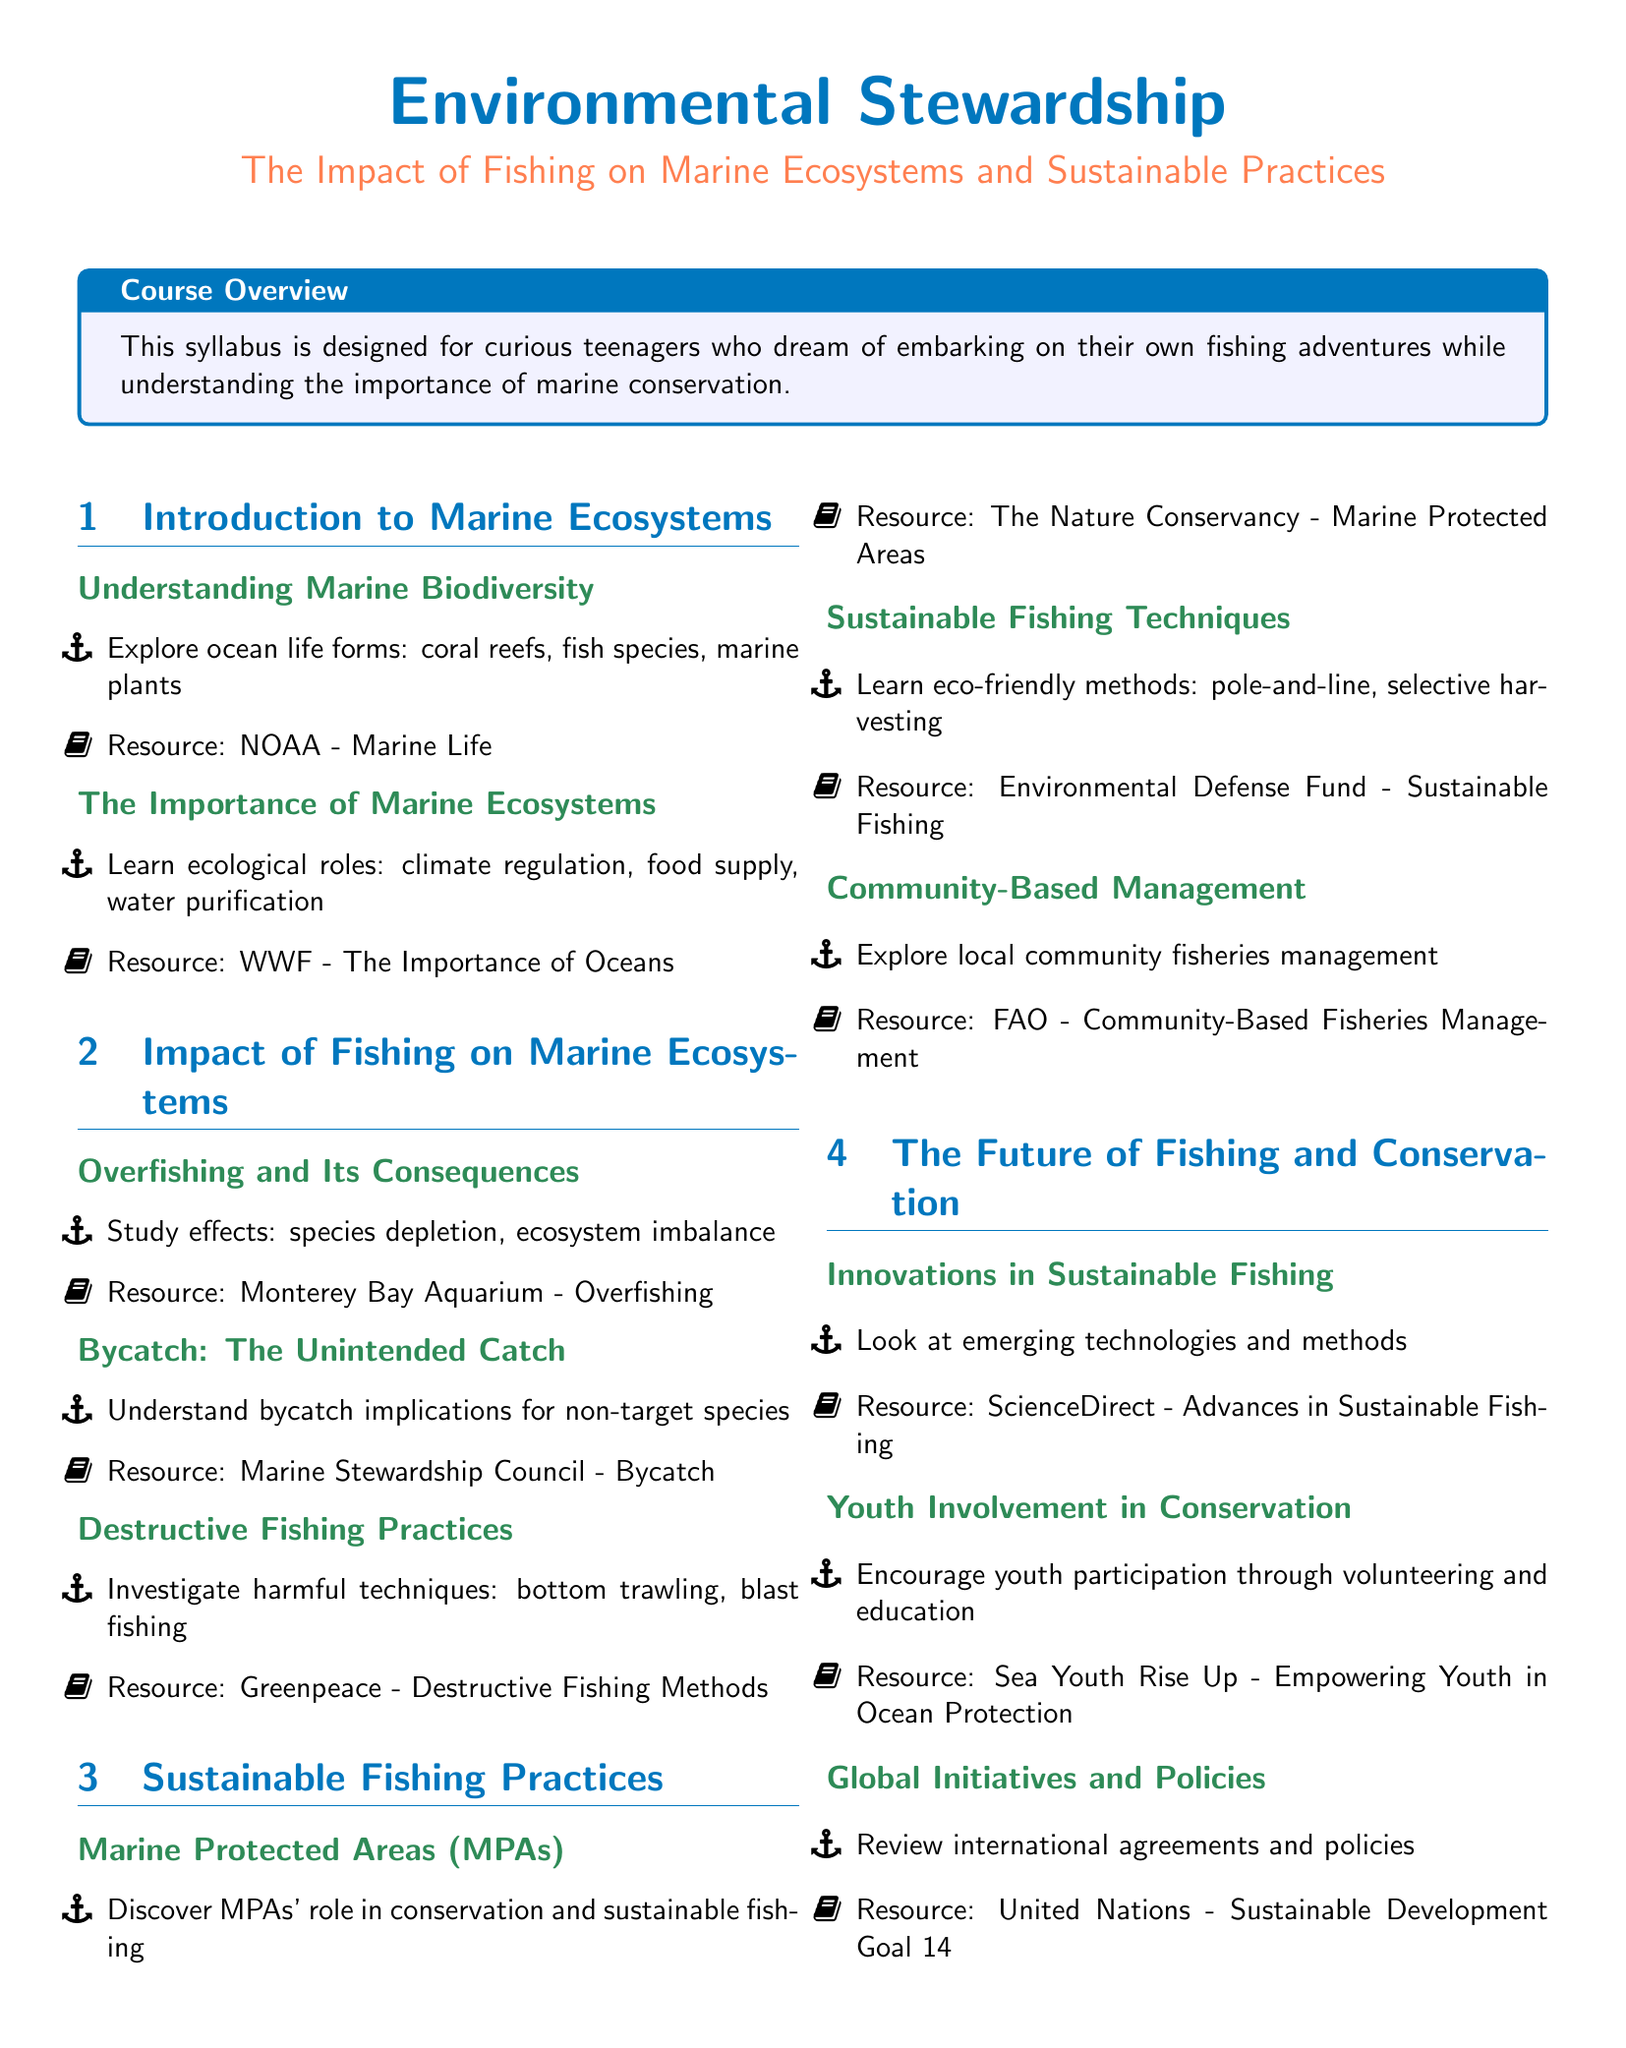What is the course title? The title provides insight into the main subject the syllabus covers, which is focused on fishing and marine ecosystems.
Answer: The Impact of Fishing on Marine Ecosystems and Sustainable Practices Who published the resource "Marine Life"? This document includes cited resources associated with specific topics that deepen understanding of marine ecosystems.
Answer: NOAA What technique is associated with harmful practices like blast fishing? The syllabus highlights various destructive fishing techniques that adversely affect marine ecosystems.
Answer: Destructive Fishing Practices What are Marine Protected Areas abbreviated as? The abbreviation for Marine Protected Areas indicates a key term used in discussing conservation efforts.
Answer: MPAs What role do MPAs play in fishing? Understanding the impact of Marine Protected Areas is essential for both conservation and sustainable fishing discussions.
Answer: Conservation and sustainable fishing Which organization focuses on youth participation in ocean protection? This resource in the syllabus emphasizes the importance of involving youth in conservation efforts.
Answer: Sea Youth Rise Up How many sections are in the syllabus? The number of sections reflects the structure and topics covered throughout the syllabus.
Answer: Four What is the emphasis of the course overview? The course overview gives insight into the primary audience and the overarching theme of the syllabus.
Answer: Marine conservation What is one type of sustainable fishing technique mentioned? The document outlines various eco-friendly methods of fishing that contribute to sustainability efforts.
Answer: Pole-and-line 